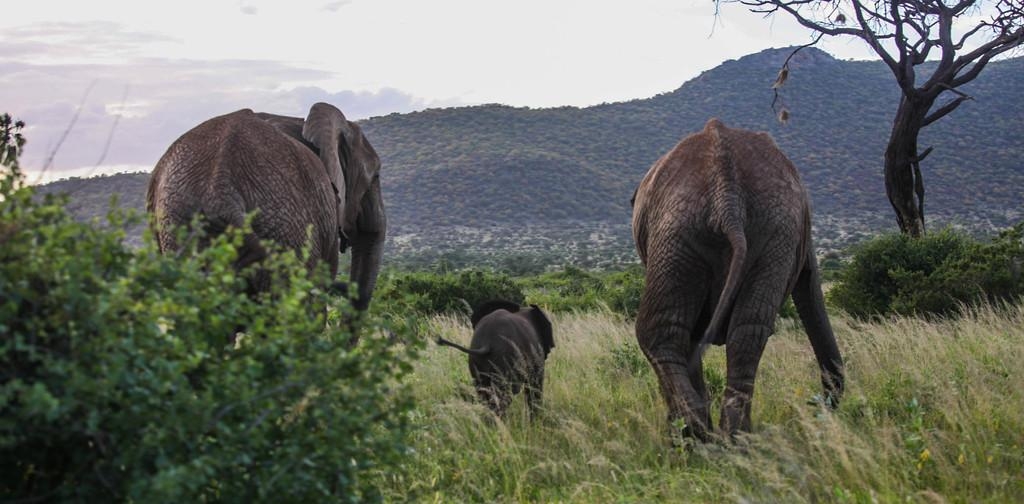How many adult elephants are in the image? There are two adult elephants in the image. What other type of elephant is present in the image? There is a calf in the image. Where are the elephants and calf located in the image? They are in the middle of the image. What type of terrain is visible in the image? There are hills, grass, and trees visible in the image. What is visible at the top of the image? The sky is visible at the top of the image, and there are clouds in the sky. How many pigs are in the image? There are no pigs present in the image; it features elephants and a calf. Where is the sink located in the image? There is no sink present in the image. 